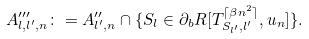<formula> <loc_0><loc_0><loc_500><loc_500>A ^ { \prime \prime \prime } _ { l , l ^ { \prime } , n } \colon = A ^ { \prime \prime } _ { l ^ { \prime } , n } \cap \{ S _ { l } \in \partial _ { b } R [ T _ { S _ { l ^ { \prime } } , l ^ { \prime } } ^ { \lceil \beta n ^ { 2 } \rceil } , u _ { n } ] \} .</formula> 